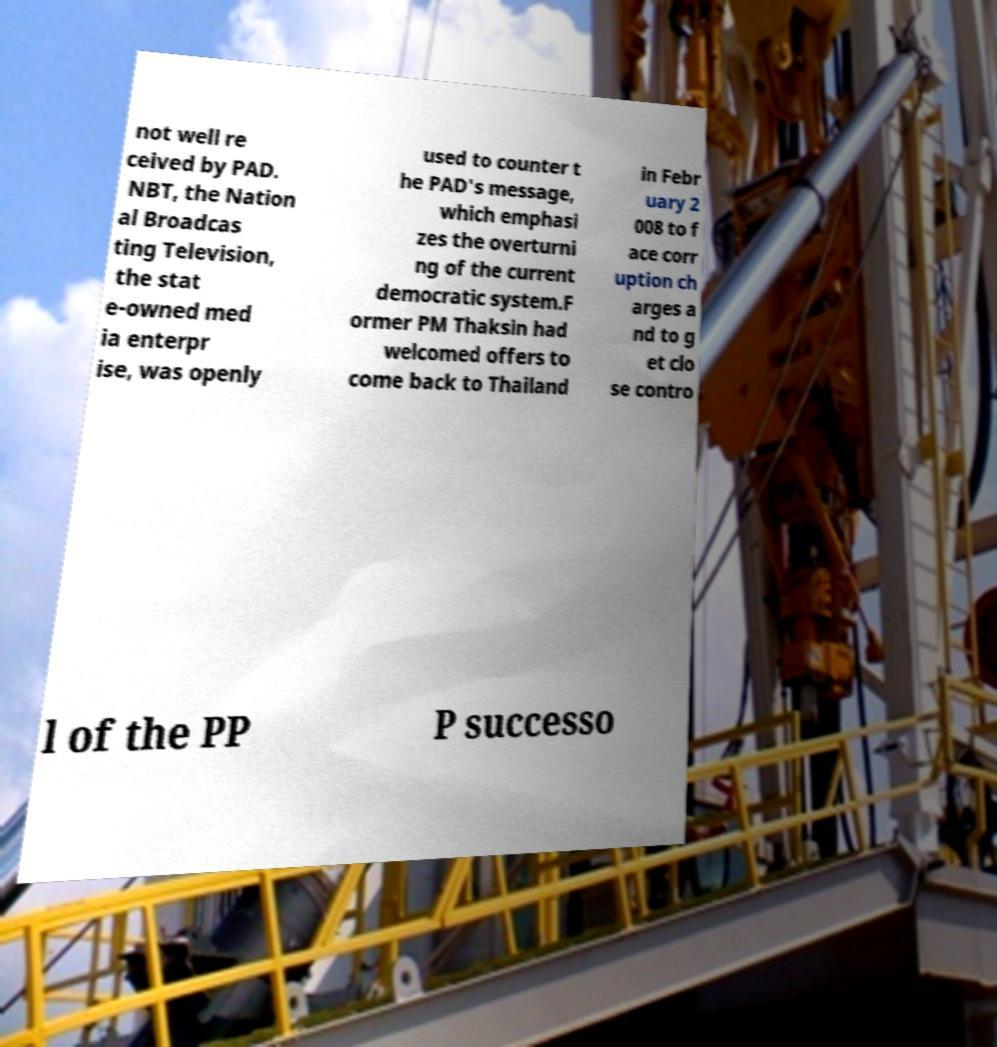I need the written content from this picture converted into text. Can you do that? not well re ceived by PAD. NBT, the Nation al Broadcas ting Television, the stat e-owned med ia enterpr ise, was openly used to counter t he PAD's message, which emphasi zes the overturni ng of the current democratic system.F ormer PM Thaksin had welcomed offers to come back to Thailand in Febr uary 2 008 to f ace corr uption ch arges a nd to g et clo se contro l of the PP P successo 